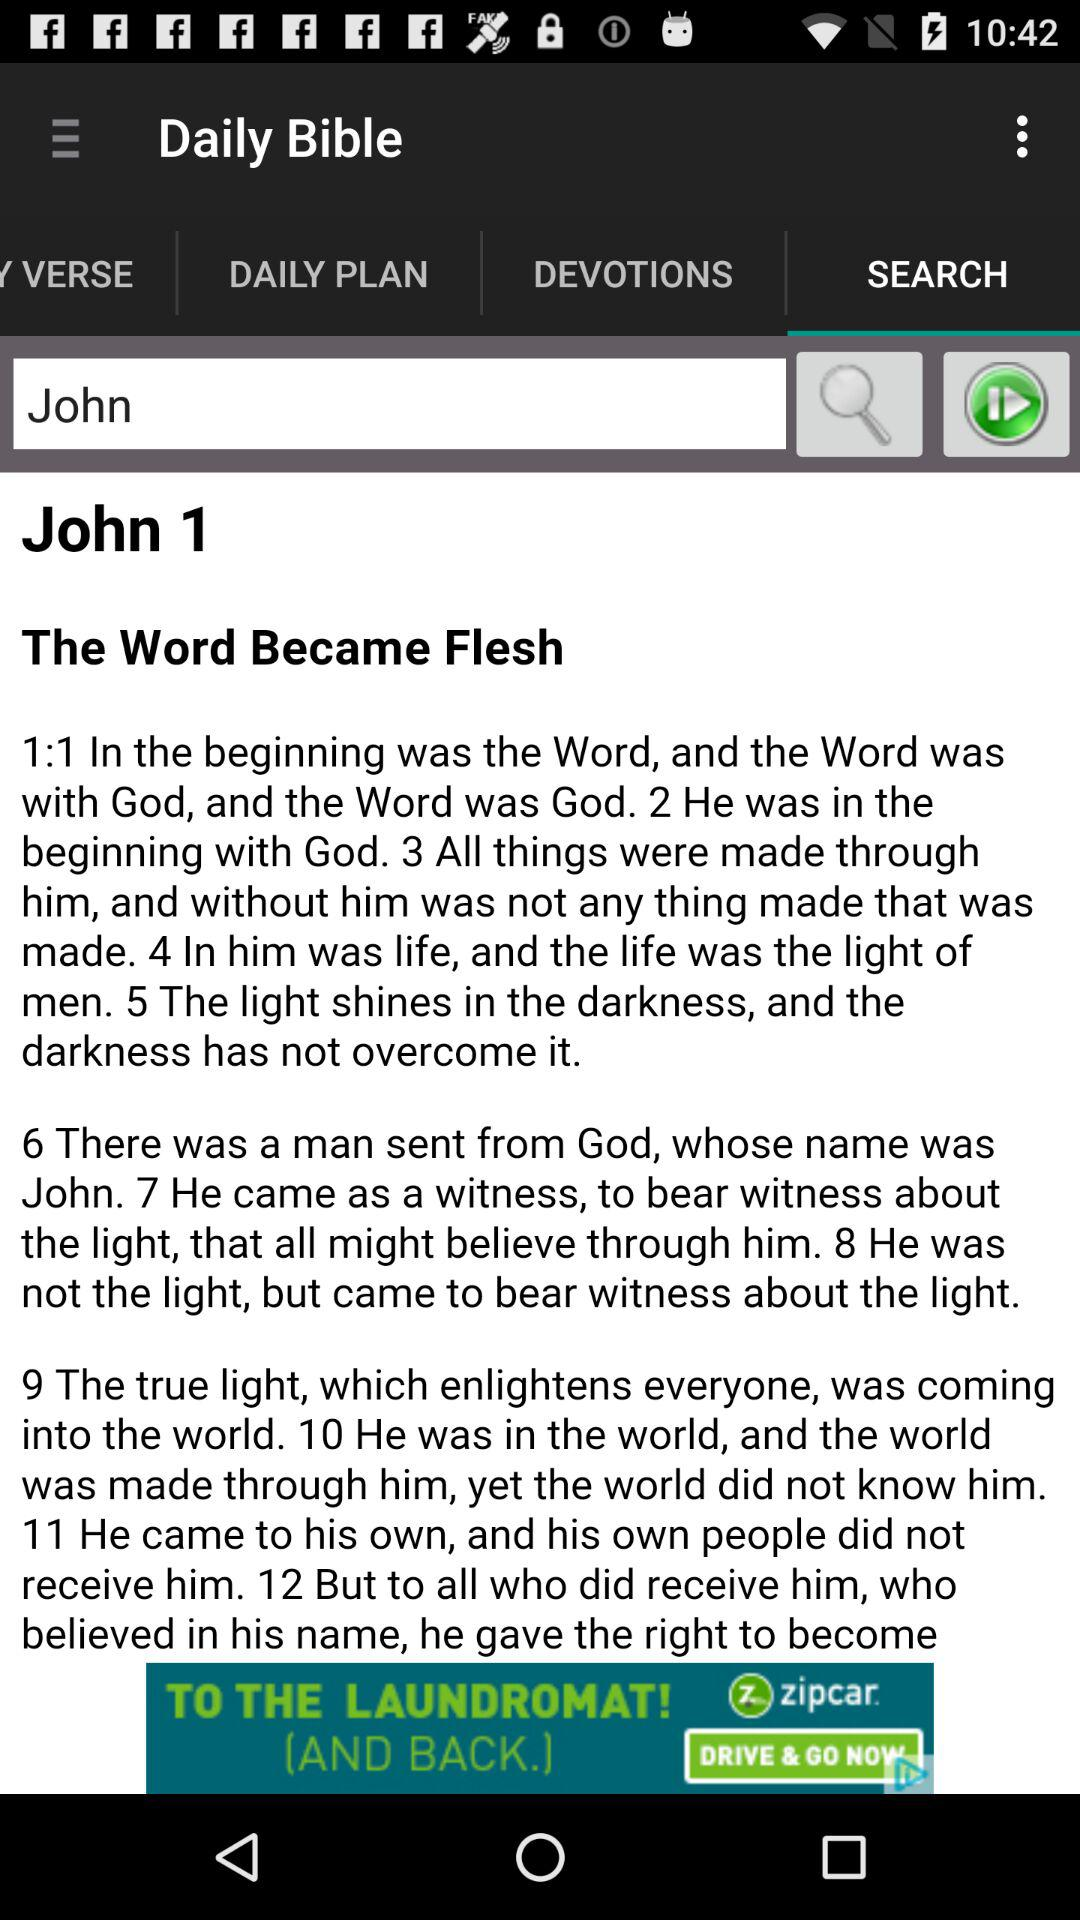Which tab is selected? The selected tab is "SEARCH". 